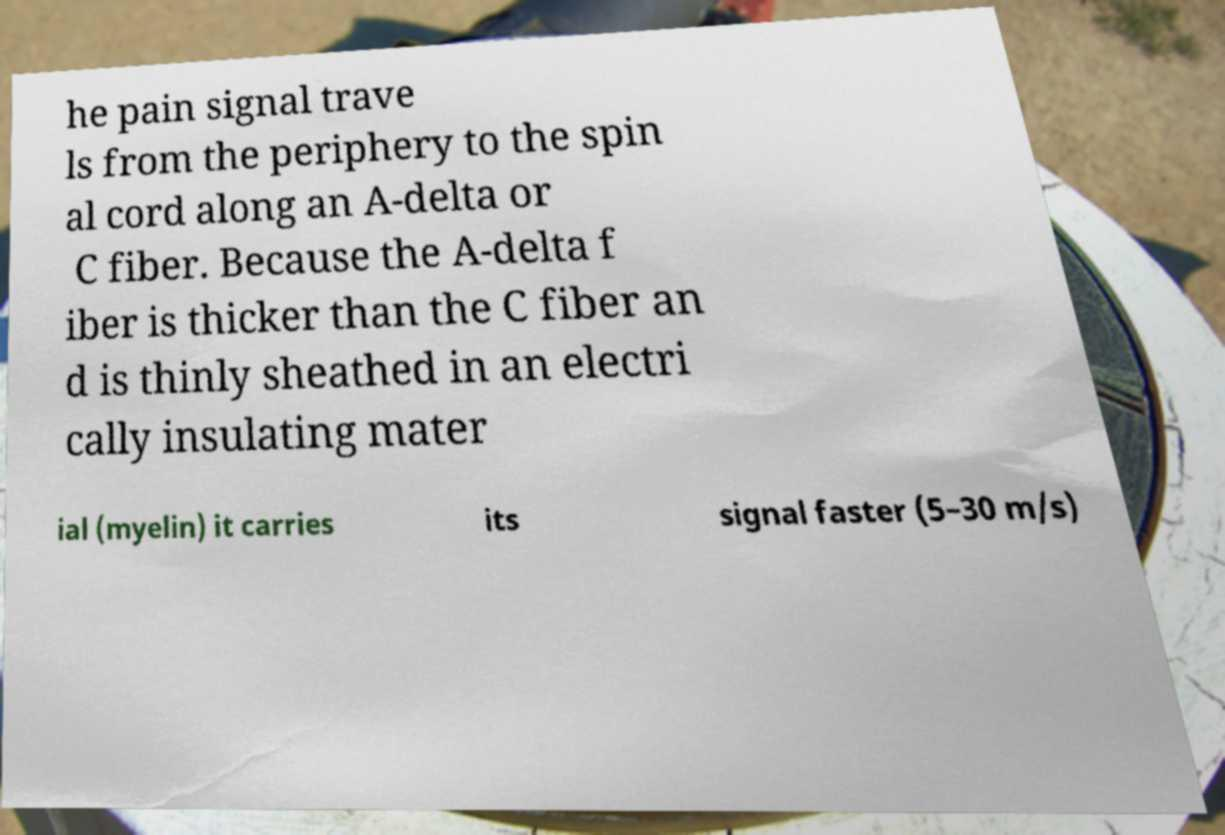Please read and relay the text visible in this image. What does it say? he pain signal trave ls from the periphery to the spin al cord along an A-delta or C fiber. Because the A-delta f iber is thicker than the C fiber an d is thinly sheathed in an electri cally insulating mater ial (myelin) it carries its signal faster (5–30 m/s) 